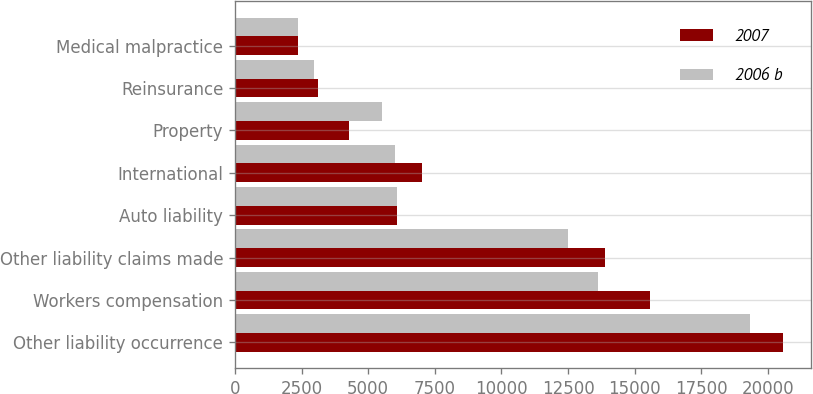Convert chart. <chart><loc_0><loc_0><loc_500><loc_500><stacked_bar_chart><ecel><fcel>Other liability occurrence<fcel>Workers compensation<fcel>Other liability claims made<fcel>Auto liability<fcel>International<fcel>Property<fcel>Reinsurance<fcel>Medical malpractice<nl><fcel>2007<fcel>20580<fcel>15568<fcel>13878<fcel>6068<fcel>7036<fcel>4274<fcel>3127<fcel>2361<nl><fcel>2006 b<fcel>19327<fcel>13612<fcel>12513<fcel>6070<fcel>6006<fcel>5499<fcel>2979<fcel>2347<nl></chart> 